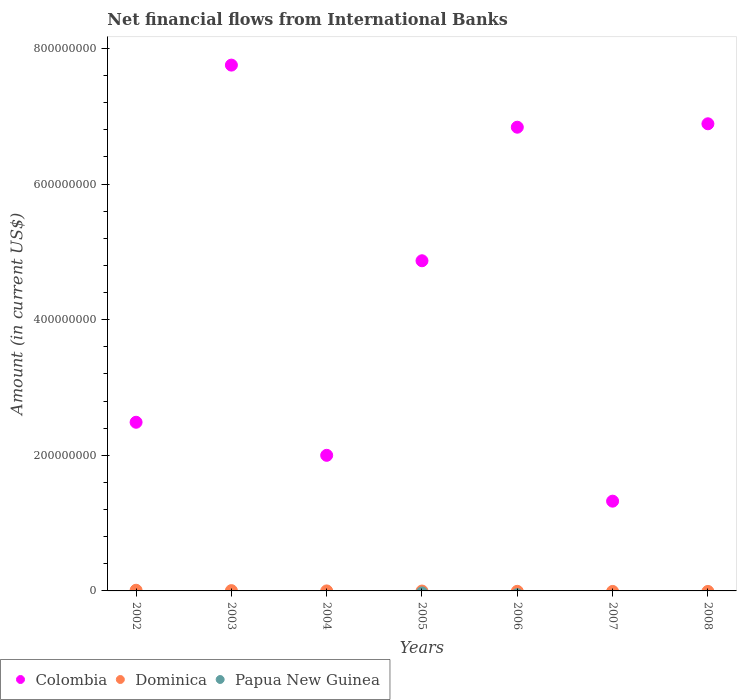What is the net financial aid flows in Colombia in 2007?
Offer a terse response. 1.32e+08. Across all years, what is the maximum net financial aid flows in Dominica?
Your answer should be compact. 9.89e+05. Across all years, what is the minimum net financial aid flows in Papua New Guinea?
Your answer should be compact. 0. What is the total net financial aid flows in Dominica in the graph?
Make the answer very short. 1.42e+06. What is the difference between the net financial aid flows in Colombia in 2005 and that in 2007?
Make the answer very short. 3.55e+08. What is the difference between the net financial aid flows in Papua New Guinea in 2004 and the net financial aid flows in Dominica in 2005?
Keep it short and to the point. 0. What is the average net financial aid flows in Dominica per year?
Ensure brevity in your answer.  2.03e+05. In the year 2004, what is the difference between the net financial aid flows in Dominica and net financial aid flows in Colombia?
Make the answer very short. -2.00e+08. What is the ratio of the net financial aid flows in Colombia in 2006 to that in 2008?
Offer a very short reply. 0.99. Is the difference between the net financial aid flows in Dominica in 2003 and 2004 greater than the difference between the net financial aid flows in Colombia in 2003 and 2004?
Provide a short and direct response. No. What is the difference between the highest and the second highest net financial aid flows in Colombia?
Keep it short and to the point. 8.65e+07. What is the difference between the highest and the lowest net financial aid flows in Dominica?
Ensure brevity in your answer.  9.89e+05. Is it the case that in every year, the sum of the net financial aid flows in Dominica and net financial aid flows in Colombia  is greater than the net financial aid flows in Papua New Guinea?
Keep it short and to the point. Yes. Does the net financial aid flows in Colombia monotonically increase over the years?
Provide a succinct answer. No. Is the net financial aid flows in Colombia strictly greater than the net financial aid flows in Papua New Guinea over the years?
Provide a short and direct response. Yes. What is the difference between two consecutive major ticks on the Y-axis?
Ensure brevity in your answer.  2.00e+08. Are the values on the major ticks of Y-axis written in scientific E-notation?
Provide a succinct answer. No. Does the graph contain any zero values?
Keep it short and to the point. Yes. How are the legend labels stacked?
Make the answer very short. Horizontal. What is the title of the graph?
Your response must be concise. Net financial flows from International Banks. What is the Amount (in current US$) of Colombia in 2002?
Your answer should be compact. 2.49e+08. What is the Amount (in current US$) of Dominica in 2002?
Your answer should be compact. 9.89e+05. What is the Amount (in current US$) of Colombia in 2003?
Ensure brevity in your answer.  7.75e+08. What is the Amount (in current US$) of Dominica in 2003?
Your response must be concise. 4.30e+05. What is the Amount (in current US$) of Papua New Guinea in 2003?
Your answer should be very brief. 0. What is the Amount (in current US$) in Colombia in 2004?
Offer a very short reply. 2.00e+08. What is the Amount (in current US$) in Dominica in 2004?
Your answer should be very brief. 4000. What is the Amount (in current US$) of Papua New Guinea in 2004?
Provide a short and direct response. 0. What is the Amount (in current US$) of Colombia in 2005?
Ensure brevity in your answer.  4.87e+08. What is the Amount (in current US$) of Dominica in 2005?
Offer a terse response. 0. What is the Amount (in current US$) in Papua New Guinea in 2005?
Ensure brevity in your answer.  0. What is the Amount (in current US$) of Colombia in 2006?
Make the answer very short. 6.84e+08. What is the Amount (in current US$) in Dominica in 2006?
Your response must be concise. 0. What is the Amount (in current US$) in Papua New Guinea in 2006?
Provide a short and direct response. 0. What is the Amount (in current US$) of Colombia in 2007?
Give a very brief answer. 1.32e+08. What is the Amount (in current US$) of Dominica in 2007?
Offer a very short reply. 0. What is the Amount (in current US$) in Papua New Guinea in 2007?
Ensure brevity in your answer.  0. What is the Amount (in current US$) in Colombia in 2008?
Offer a very short reply. 6.89e+08. What is the Amount (in current US$) in Dominica in 2008?
Offer a terse response. 0. Across all years, what is the maximum Amount (in current US$) of Colombia?
Give a very brief answer. 7.75e+08. Across all years, what is the maximum Amount (in current US$) of Dominica?
Provide a succinct answer. 9.89e+05. Across all years, what is the minimum Amount (in current US$) in Colombia?
Offer a very short reply. 1.32e+08. Across all years, what is the minimum Amount (in current US$) of Dominica?
Offer a terse response. 0. What is the total Amount (in current US$) in Colombia in the graph?
Make the answer very short. 3.22e+09. What is the total Amount (in current US$) in Dominica in the graph?
Offer a terse response. 1.42e+06. What is the total Amount (in current US$) in Papua New Guinea in the graph?
Provide a short and direct response. 0. What is the difference between the Amount (in current US$) of Colombia in 2002 and that in 2003?
Offer a very short reply. -5.27e+08. What is the difference between the Amount (in current US$) in Dominica in 2002 and that in 2003?
Your response must be concise. 5.59e+05. What is the difference between the Amount (in current US$) of Colombia in 2002 and that in 2004?
Your answer should be very brief. 4.88e+07. What is the difference between the Amount (in current US$) of Dominica in 2002 and that in 2004?
Provide a short and direct response. 9.85e+05. What is the difference between the Amount (in current US$) in Colombia in 2002 and that in 2005?
Your response must be concise. -2.38e+08. What is the difference between the Amount (in current US$) of Colombia in 2002 and that in 2006?
Your response must be concise. -4.35e+08. What is the difference between the Amount (in current US$) of Colombia in 2002 and that in 2007?
Your answer should be compact. 1.16e+08. What is the difference between the Amount (in current US$) in Colombia in 2002 and that in 2008?
Keep it short and to the point. -4.40e+08. What is the difference between the Amount (in current US$) of Colombia in 2003 and that in 2004?
Your response must be concise. 5.76e+08. What is the difference between the Amount (in current US$) in Dominica in 2003 and that in 2004?
Your response must be concise. 4.26e+05. What is the difference between the Amount (in current US$) of Colombia in 2003 and that in 2005?
Offer a terse response. 2.89e+08. What is the difference between the Amount (in current US$) of Colombia in 2003 and that in 2006?
Make the answer very short. 9.16e+07. What is the difference between the Amount (in current US$) of Colombia in 2003 and that in 2007?
Offer a terse response. 6.43e+08. What is the difference between the Amount (in current US$) in Colombia in 2003 and that in 2008?
Keep it short and to the point. 8.65e+07. What is the difference between the Amount (in current US$) of Colombia in 2004 and that in 2005?
Offer a terse response. -2.87e+08. What is the difference between the Amount (in current US$) in Colombia in 2004 and that in 2006?
Offer a terse response. -4.84e+08. What is the difference between the Amount (in current US$) in Colombia in 2004 and that in 2007?
Your answer should be very brief. 6.76e+07. What is the difference between the Amount (in current US$) in Colombia in 2004 and that in 2008?
Make the answer very short. -4.89e+08. What is the difference between the Amount (in current US$) in Colombia in 2005 and that in 2006?
Offer a very short reply. -1.97e+08. What is the difference between the Amount (in current US$) of Colombia in 2005 and that in 2007?
Make the answer very short. 3.55e+08. What is the difference between the Amount (in current US$) of Colombia in 2005 and that in 2008?
Give a very brief answer. -2.02e+08. What is the difference between the Amount (in current US$) in Colombia in 2006 and that in 2007?
Provide a succinct answer. 5.52e+08. What is the difference between the Amount (in current US$) of Colombia in 2006 and that in 2008?
Your answer should be compact. -5.05e+06. What is the difference between the Amount (in current US$) in Colombia in 2007 and that in 2008?
Your answer should be compact. -5.57e+08. What is the difference between the Amount (in current US$) in Colombia in 2002 and the Amount (in current US$) in Dominica in 2003?
Your answer should be compact. 2.48e+08. What is the difference between the Amount (in current US$) of Colombia in 2002 and the Amount (in current US$) of Dominica in 2004?
Keep it short and to the point. 2.49e+08. What is the difference between the Amount (in current US$) of Colombia in 2003 and the Amount (in current US$) of Dominica in 2004?
Keep it short and to the point. 7.75e+08. What is the average Amount (in current US$) of Colombia per year?
Provide a short and direct response. 4.59e+08. What is the average Amount (in current US$) of Dominica per year?
Your answer should be compact. 2.03e+05. What is the average Amount (in current US$) in Papua New Guinea per year?
Your response must be concise. 0. In the year 2002, what is the difference between the Amount (in current US$) of Colombia and Amount (in current US$) of Dominica?
Make the answer very short. 2.48e+08. In the year 2003, what is the difference between the Amount (in current US$) of Colombia and Amount (in current US$) of Dominica?
Offer a very short reply. 7.75e+08. In the year 2004, what is the difference between the Amount (in current US$) of Colombia and Amount (in current US$) of Dominica?
Keep it short and to the point. 2.00e+08. What is the ratio of the Amount (in current US$) in Colombia in 2002 to that in 2003?
Your response must be concise. 0.32. What is the ratio of the Amount (in current US$) of Dominica in 2002 to that in 2003?
Provide a succinct answer. 2.3. What is the ratio of the Amount (in current US$) of Colombia in 2002 to that in 2004?
Offer a very short reply. 1.24. What is the ratio of the Amount (in current US$) in Dominica in 2002 to that in 2004?
Provide a short and direct response. 247.25. What is the ratio of the Amount (in current US$) in Colombia in 2002 to that in 2005?
Keep it short and to the point. 0.51. What is the ratio of the Amount (in current US$) in Colombia in 2002 to that in 2006?
Provide a short and direct response. 0.36. What is the ratio of the Amount (in current US$) of Colombia in 2002 to that in 2007?
Offer a terse response. 1.88. What is the ratio of the Amount (in current US$) of Colombia in 2002 to that in 2008?
Keep it short and to the point. 0.36. What is the ratio of the Amount (in current US$) in Colombia in 2003 to that in 2004?
Ensure brevity in your answer.  3.88. What is the ratio of the Amount (in current US$) of Dominica in 2003 to that in 2004?
Your answer should be very brief. 107.5. What is the ratio of the Amount (in current US$) of Colombia in 2003 to that in 2005?
Provide a succinct answer. 1.59. What is the ratio of the Amount (in current US$) in Colombia in 2003 to that in 2006?
Offer a very short reply. 1.13. What is the ratio of the Amount (in current US$) of Colombia in 2003 to that in 2007?
Keep it short and to the point. 5.86. What is the ratio of the Amount (in current US$) of Colombia in 2003 to that in 2008?
Give a very brief answer. 1.13. What is the ratio of the Amount (in current US$) of Colombia in 2004 to that in 2005?
Your answer should be compact. 0.41. What is the ratio of the Amount (in current US$) of Colombia in 2004 to that in 2006?
Make the answer very short. 0.29. What is the ratio of the Amount (in current US$) in Colombia in 2004 to that in 2007?
Make the answer very short. 1.51. What is the ratio of the Amount (in current US$) of Colombia in 2004 to that in 2008?
Your answer should be compact. 0.29. What is the ratio of the Amount (in current US$) of Colombia in 2005 to that in 2006?
Keep it short and to the point. 0.71. What is the ratio of the Amount (in current US$) in Colombia in 2005 to that in 2007?
Make the answer very short. 3.68. What is the ratio of the Amount (in current US$) of Colombia in 2005 to that in 2008?
Provide a short and direct response. 0.71. What is the ratio of the Amount (in current US$) in Colombia in 2006 to that in 2007?
Your answer should be compact. 5.17. What is the ratio of the Amount (in current US$) of Colombia in 2006 to that in 2008?
Ensure brevity in your answer.  0.99. What is the ratio of the Amount (in current US$) in Colombia in 2007 to that in 2008?
Your answer should be very brief. 0.19. What is the difference between the highest and the second highest Amount (in current US$) of Colombia?
Your answer should be compact. 8.65e+07. What is the difference between the highest and the second highest Amount (in current US$) in Dominica?
Provide a short and direct response. 5.59e+05. What is the difference between the highest and the lowest Amount (in current US$) of Colombia?
Provide a short and direct response. 6.43e+08. What is the difference between the highest and the lowest Amount (in current US$) of Dominica?
Keep it short and to the point. 9.89e+05. 